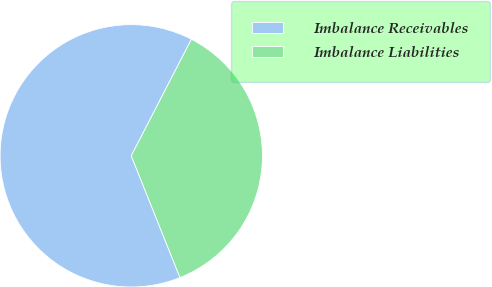Convert chart to OTSL. <chart><loc_0><loc_0><loc_500><loc_500><pie_chart><fcel>Imbalance Receivables<fcel>Imbalance Liabilities<nl><fcel>63.64%<fcel>36.36%<nl></chart> 